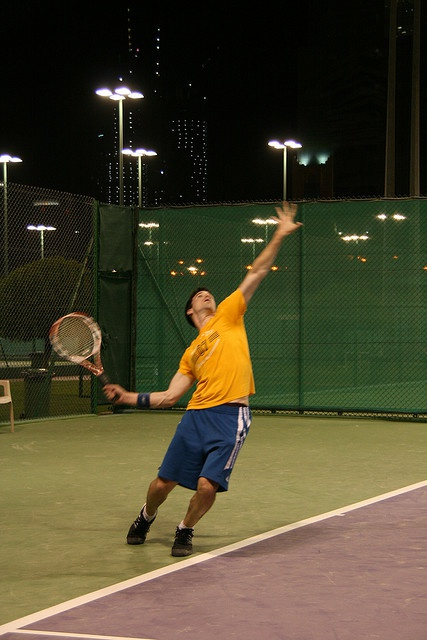Describe the objects in this image and their specific colors. I can see people in black, orange, navy, and brown tones and tennis racket in black, olive, gray, and maroon tones in this image. 